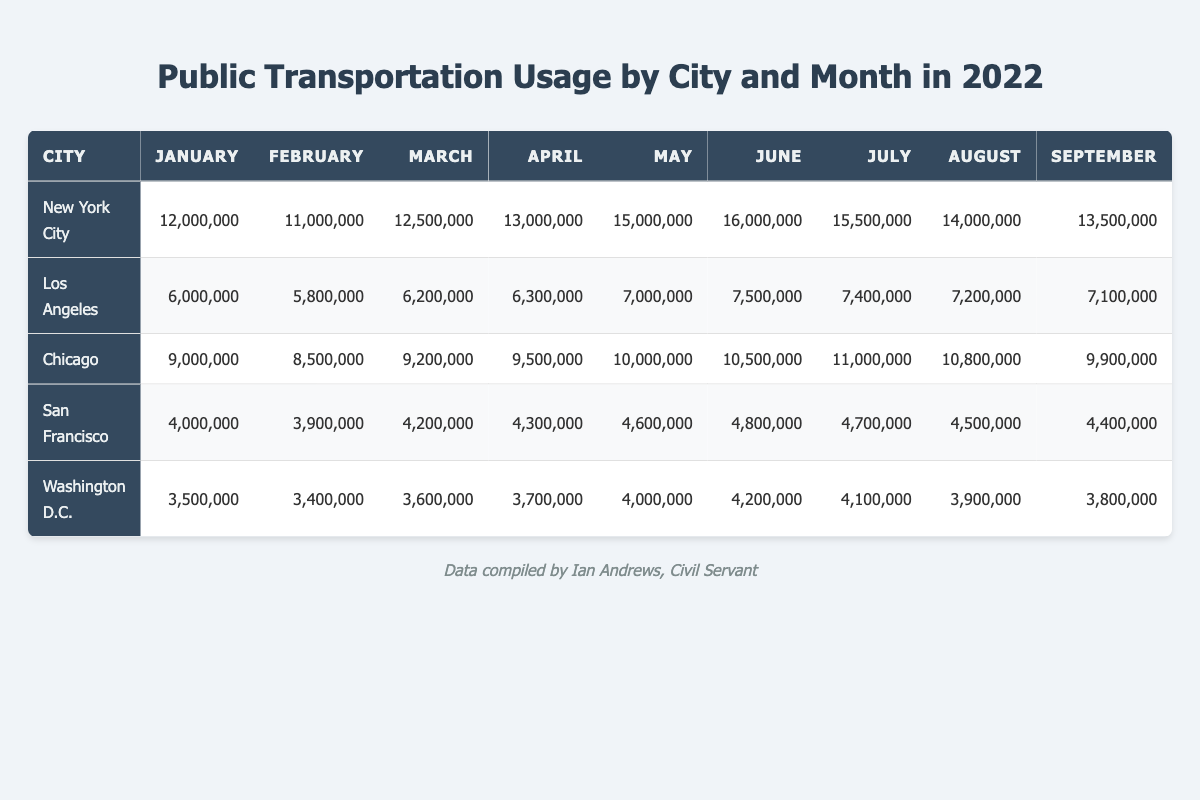What was the public transportation usage in New York City in June? Referring to the table, New York City's public transportation usage in June is listed as 16,000,000.
Answer: 16,000,000 Which city had the highest public transportation usage in May? The table shows New York City had the highest usage in May with 15,000,000, compared to other cities.
Answer: New York City What is the total public transportation usage in Los Angeles for the entire year? Adding the monthly values for Los Angeles gives: 6,000,000 + 5,800,000 + 6,200,000 + 6,300,000 + 7,000,000 + 7,500,000 + 7,400,000 + 7,200,000 + 7,100,000 + 7,300,000 + 6,800,000 + 6,900,000 = 83,600,000.
Answer: 83,600,000 Did San Francisco's public transportation usage ever exceed 5 million in 2022? Looking through the monthly data for San Francisco, all values are below 5 million, confirming the answer is no.
Answer: No What was the average public transportation usage in Chicago from March to June? The values for Chicago from March to June are 9,200,000, 9,500,000, 10,000,000, and 10,500,000. The sum is 39,200,000 and dividing it by 4 gives an average of 9,800,000.
Answer: 9,800,000 Which month saw the most significant decrease in public transportation usage for Washington D.C.? Comparing the monthly values, the largest decrease is from July (4,100,000) to August (3,900,000), which is a decrease of 200,000.
Answer: August What was the total public transportation usage across all cities in December? Summing the December values: 15,000,000 (NYC) + 6,900,000 (LA) + 9,800,000 (Chicago) + 4,300,000 (SF) + 3,600,000 (D.C.) equals 39,600,000.
Answer: 39,600,000 Which city has the least total public transportation usage throughout the year? By comparing total usages, San Francisco with 52,200,000 has the lowest total compared to others.
Answer: San Francisco What is the percentage increase in public transportation usage in New York City from January to June? Usage in January is 12,000,000 and June is 16,000,000. The increase is 4,000,000, leading to a percentage of (4,000,000 / 12,000,000) * 100 = 33.33%.
Answer: 33.33% In which month did Los Angeles peak in public transportation usage? The data indicates that Los Angeles peaked at 7,500,000 in June.
Answer: June 